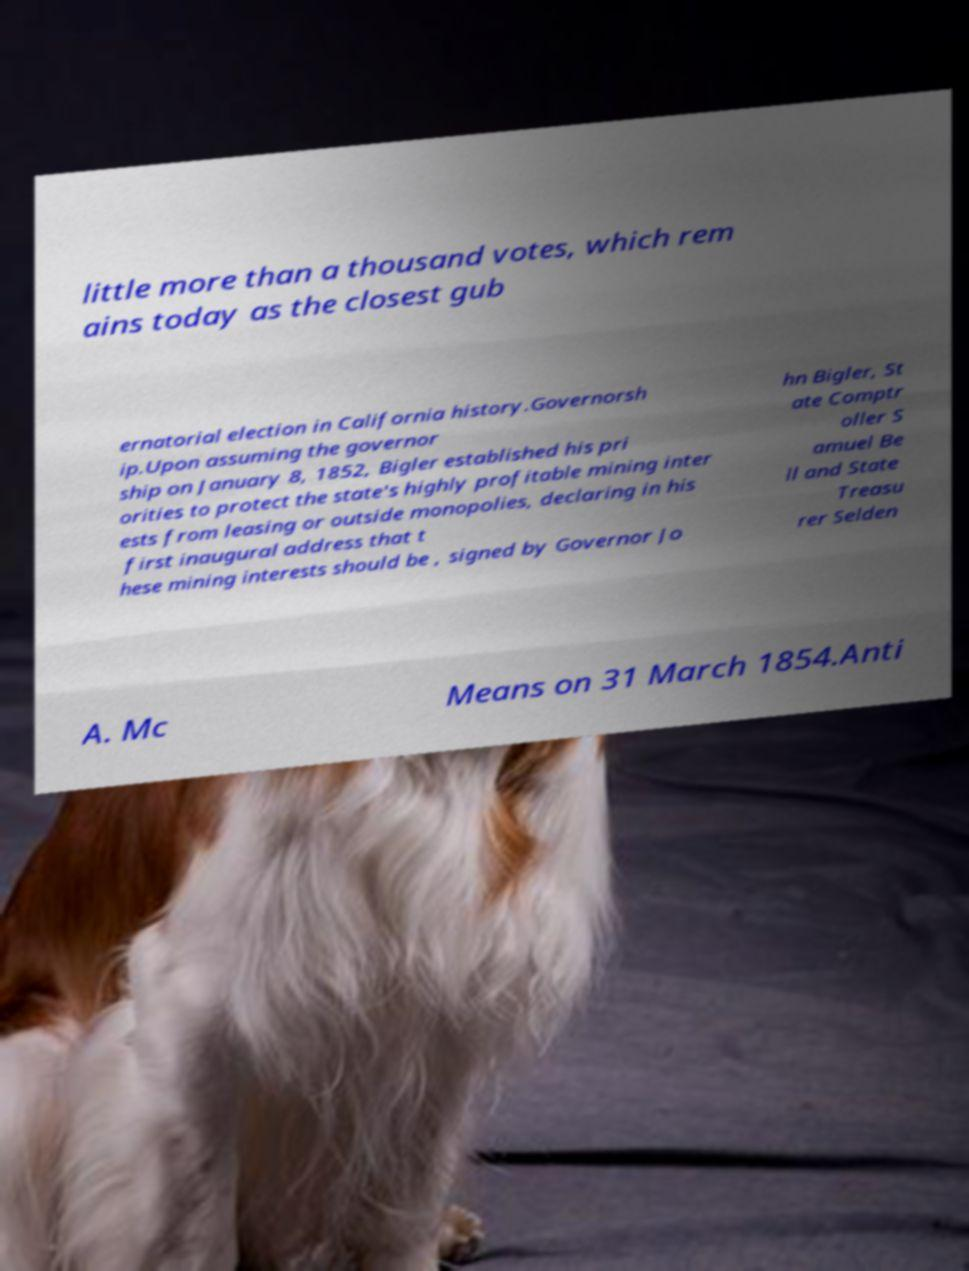Could you assist in decoding the text presented in this image and type it out clearly? little more than a thousand votes, which rem ains today as the closest gub ernatorial election in California history.Governorsh ip.Upon assuming the governor ship on January 8, 1852, Bigler established his pri orities to protect the state's highly profitable mining inter ests from leasing or outside monopolies, declaring in his first inaugural address that t hese mining interests should be , signed by Governor Jo hn Bigler, St ate Comptr oller S amuel Be ll and State Treasu rer Selden A. Mc Means on 31 March 1854.Anti 